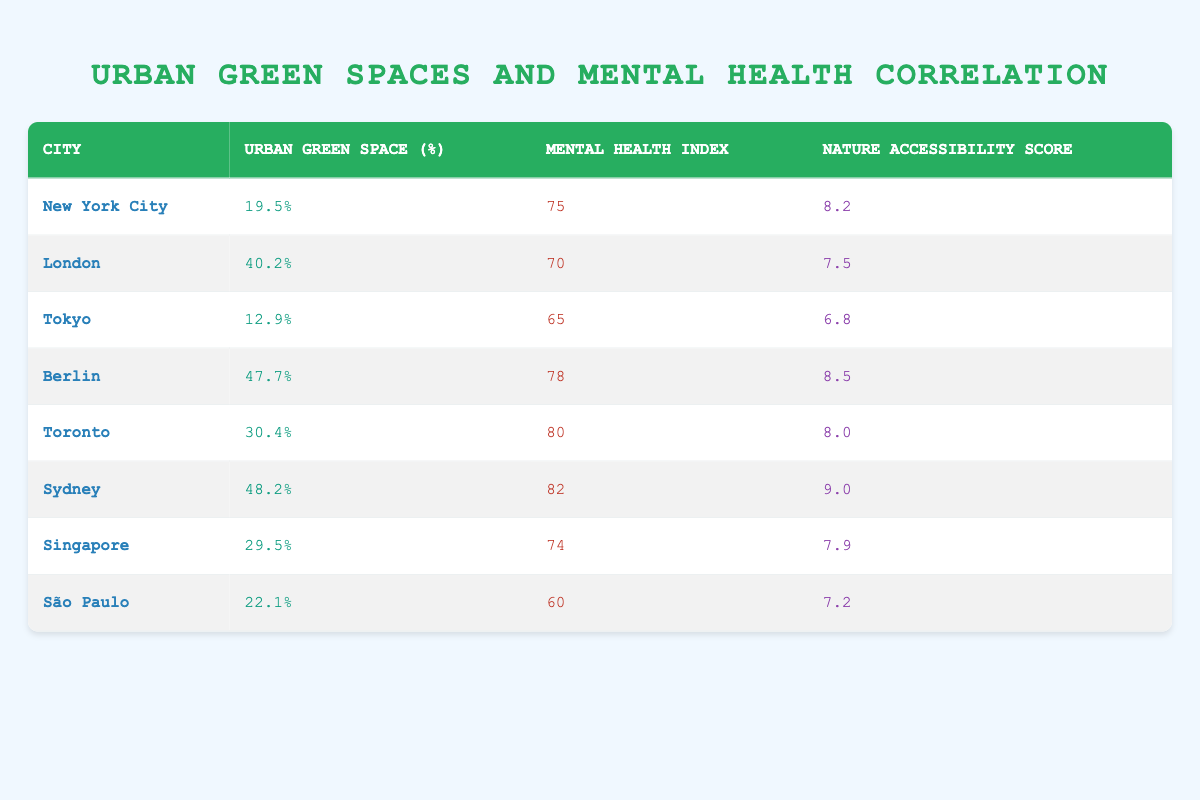What is the mental health index of Sydney? According to the table, the mental health index for Sydney is clearly indicated as 82.
Answer: 82 Which city has the highest percentage of urban green space? From the table, Sydney has the highest percentage of urban green space at 48.2%.
Answer: 48.2% Is the nature accessibility score of Berlin higher than that of Tokyo? The nature accessibility score for Berlin is 8.5, while for Tokyo it is 6.8. Since 8.5 is greater than 6.8, the statement is true.
Answer: Yes What is the average mental health index of the cities listed? To find the average, sum all the mental health indices: 75 + 70 + 65 + 78 + 80 + 82 + 74 + 60 = 584. There are 8 cities, so the average is 584/8 = 73.
Answer: 73 How does the urban green space percentage of Toronto compare to that of São Paulo? Toronto has an urban green space percentage of 30.4%, while São Paulo has 22.1%. Since 30.4% is greater than 22.1%, Toronto has more urban green space than São Paulo.
Answer: Toronto has more urban green space Which city has the closest nature accessibility score to London? By comparing the nature accessibility scores, London has 7.5, and the closest scores are from Singapore with 7.9 and Tokyo with 6.8. 7.9 is closer to 7.5 than 6.8.
Answer: Singapore Do cities with higher urban green space percentages tend to have higher mental health indices overall? Comparing the data, cities like Sydney and Berlin have high urban green space percentages and high mental health indices, while lower green space cities like São Paulo have lower mental health indices. Hence, there appears to be a correlation, supporting the statement as true.
Answer: Yes What is the difference in urban green space percentage between Berlin and New York City? Berlin's urban green space percentage is 47.7% and New York City's is 19.5%. Subtracting these values gives 47.7 - 19.5 = 28.2%.
Answer: 28.2% 